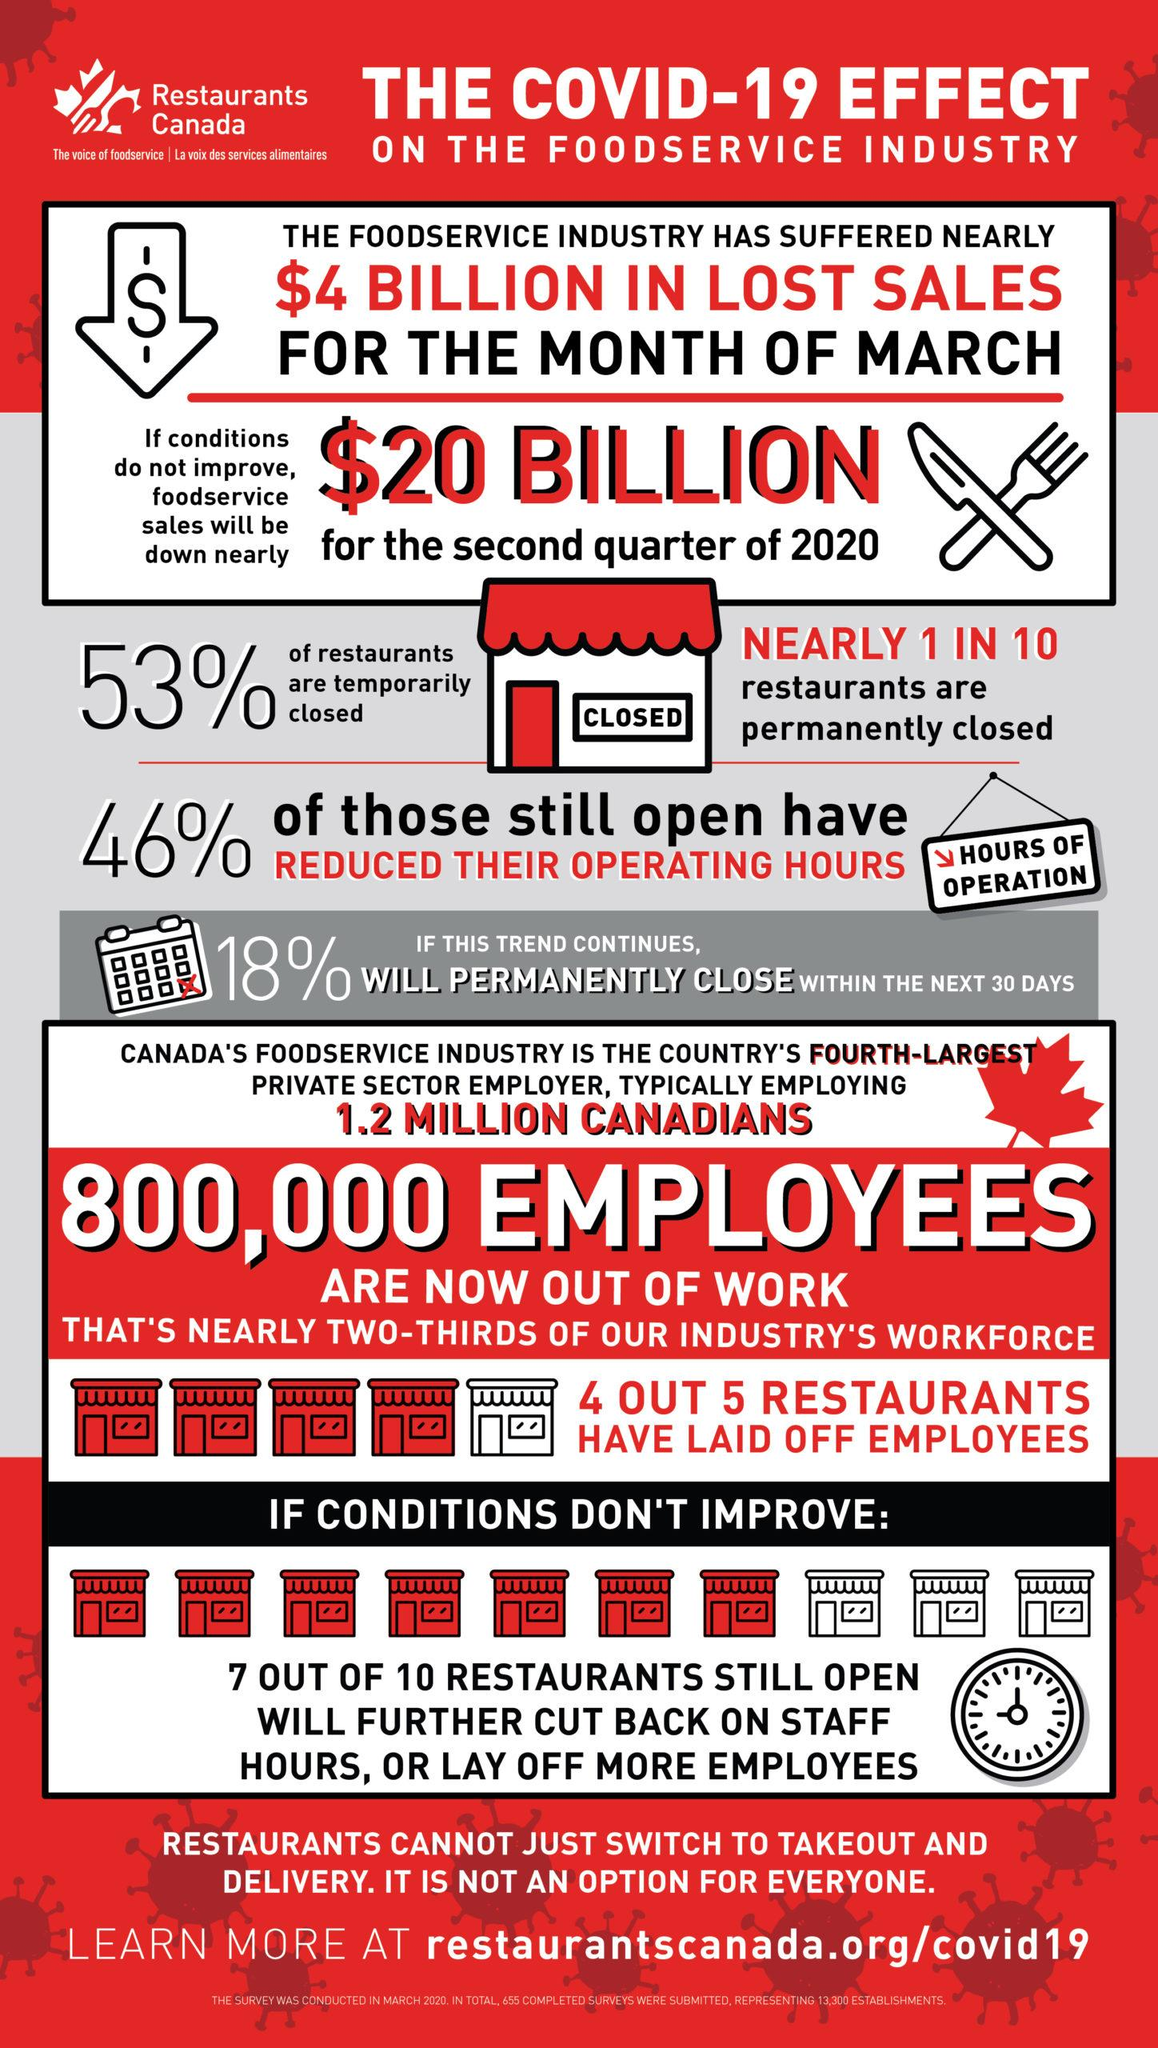Identify some key points in this picture. A majority of restaurants that are still open are considering reducing the hours of their staff or laying off more employees, according to a survey. Approximately 10% of restaurants are permanently closed. The color of the door of the restaurant is red. The predicted reduction in sales for the second quarter of 2020 is expected to be $20 billion. The message written on the wall of the restaurant indicates that it is currently closed. 